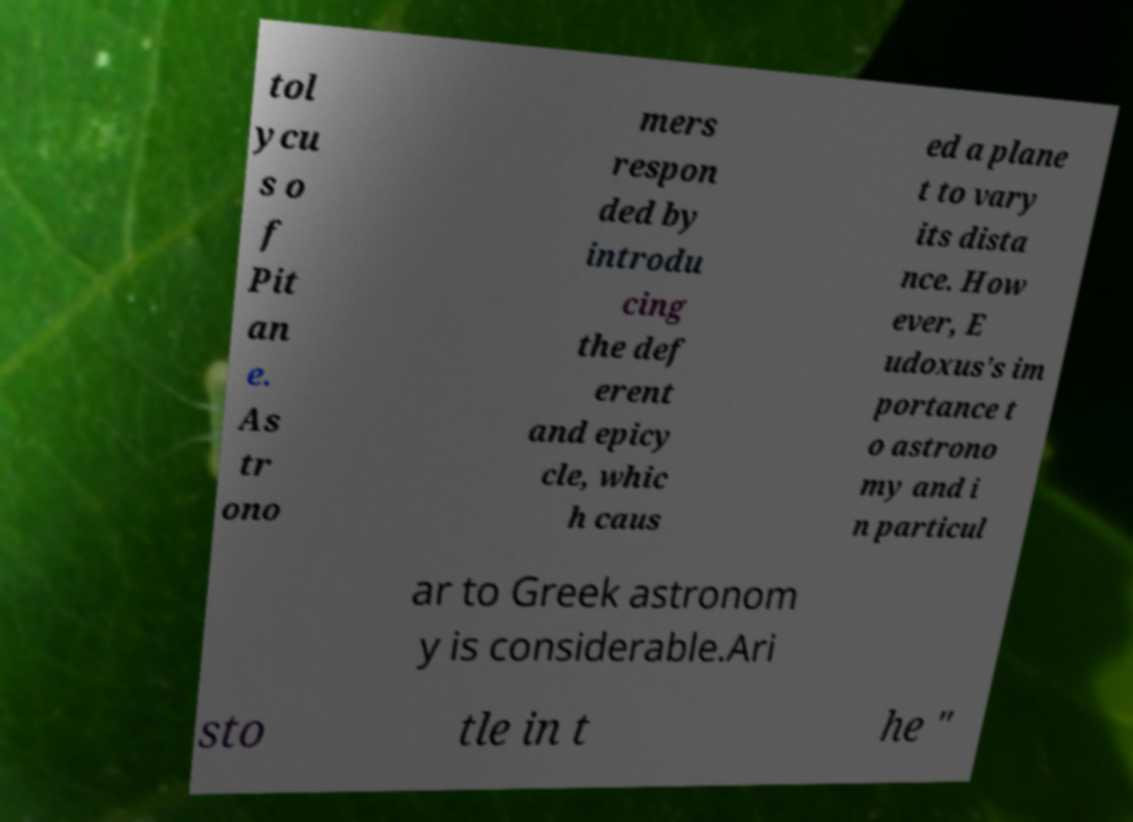What messages or text are displayed in this image? I need them in a readable, typed format. tol ycu s o f Pit an e. As tr ono mers respon ded by introdu cing the def erent and epicy cle, whic h caus ed a plane t to vary its dista nce. How ever, E udoxus's im portance t o astrono my and i n particul ar to Greek astronom y is considerable.Ari sto tle in t he " 